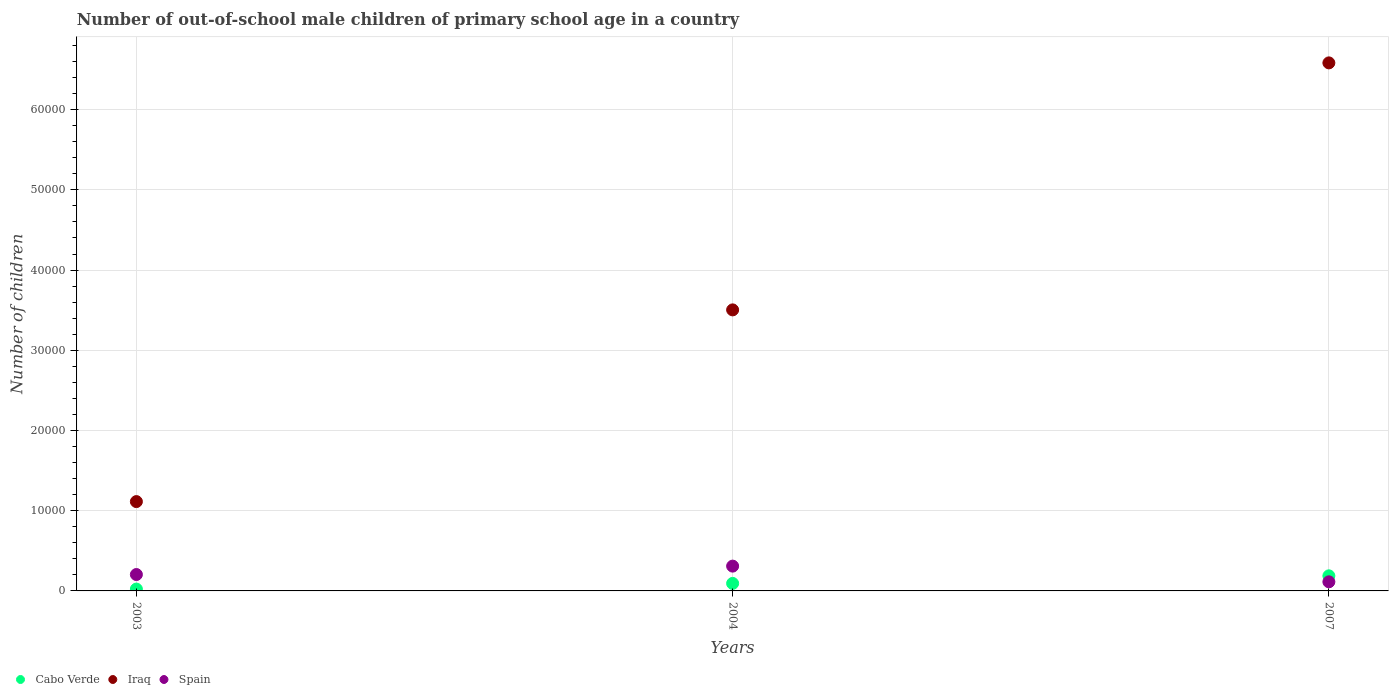What is the number of out-of-school male children in Spain in 2007?
Your answer should be compact. 1134. Across all years, what is the maximum number of out-of-school male children in Iraq?
Your answer should be compact. 6.58e+04. Across all years, what is the minimum number of out-of-school male children in Spain?
Ensure brevity in your answer.  1134. In which year was the number of out-of-school male children in Spain maximum?
Your answer should be compact. 2004. In which year was the number of out-of-school male children in Spain minimum?
Give a very brief answer. 2007. What is the total number of out-of-school male children in Spain in the graph?
Provide a short and direct response. 6270. What is the difference between the number of out-of-school male children in Iraq in 2004 and that in 2007?
Offer a very short reply. -3.08e+04. What is the difference between the number of out-of-school male children in Cabo Verde in 2003 and the number of out-of-school male children in Iraq in 2007?
Make the answer very short. -6.56e+04. What is the average number of out-of-school male children in Cabo Verde per year?
Give a very brief answer. 1016. In the year 2007, what is the difference between the number of out-of-school male children in Spain and number of out-of-school male children in Iraq?
Offer a very short reply. -6.47e+04. In how many years, is the number of out-of-school male children in Iraq greater than 30000?
Offer a very short reply. 2. What is the ratio of the number of out-of-school male children in Iraq in 2004 to that in 2007?
Your answer should be compact. 0.53. Is the number of out-of-school male children in Spain in 2003 less than that in 2004?
Provide a short and direct response. Yes. Is the difference between the number of out-of-school male children in Spain in 2003 and 2007 greater than the difference between the number of out-of-school male children in Iraq in 2003 and 2007?
Make the answer very short. Yes. What is the difference between the highest and the second highest number of out-of-school male children in Iraq?
Offer a terse response. 3.08e+04. What is the difference between the highest and the lowest number of out-of-school male children in Iraq?
Ensure brevity in your answer.  5.47e+04. In how many years, is the number of out-of-school male children in Iraq greater than the average number of out-of-school male children in Iraq taken over all years?
Ensure brevity in your answer.  1. Is it the case that in every year, the sum of the number of out-of-school male children in Iraq and number of out-of-school male children in Spain  is greater than the number of out-of-school male children in Cabo Verde?
Your response must be concise. Yes. Is the number of out-of-school male children in Cabo Verde strictly greater than the number of out-of-school male children in Spain over the years?
Keep it short and to the point. No. How many dotlines are there?
Provide a succinct answer. 3. What is the difference between two consecutive major ticks on the Y-axis?
Your response must be concise. 10000. Are the values on the major ticks of Y-axis written in scientific E-notation?
Offer a terse response. No. Does the graph contain any zero values?
Your answer should be very brief. No. Does the graph contain grids?
Make the answer very short. Yes. What is the title of the graph?
Ensure brevity in your answer.  Number of out-of-school male children of primary school age in a country. Does "Niger" appear as one of the legend labels in the graph?
Your response must be concise. No. What is the label or title of the X-axis?
Offer a terse response. Years. What is the label or title of the Y-axis?
Keep it short and to the point. Number of children. What is the Number of children in Cabo Verde in 2003?
Your answer should be compact. 230. What is the Number of children in Iraq in 2003?
Offer a terse response. 1.11e+04. What is the Number of children in Spain in 2003?
Offer a terse response. 2044. What is the Number of children in Cabo Verde in 2004?
Your answer should be very brief. 937. What is the Number of children in Iraq in 2004?
Offer a terse response. 3.50e+04. What is the Number of children in Spain in 2004?
Your response must be concise. 3092. What is the Number of children in Cabo Verde in 2007?
Offer a terse response. 1881. What is the Number of children in Iraq in 2007?
Make the answer very short. 6.58e+04. What is the Number of children in Spain in 2007?
Your answer should be very brief. 1134. Across all years, what is the maximum Number of children in Cabo Verde?
Your answer should be compact. 1881. Across all years, what is the maximum Number of children of Iraq?
Your answer should be compact. 6.58e+04. Across all years, what is the maximum Number of children in Spain?
Your answer should be very brief. 3092. Across all years, what is the minimum Number of children in Cabo Verde?
Provide a short and direct response. 230. Across all years, what is the minimum Number of children in Iraq?
Offer a terse response. 1.11e+04. Across all years, what is the minimum Number of children in Spain?
Provide a short and direct response. 1134. What is the total Number of children in Cabo Verde in the graph?
Keep it short and to the point. 3048. What is the total Number of children of Iraq in the graph?
Your response must be concise. 1.12e+05. What is the total Number of children of Spain in the graph?
Offer a very short reply. 6270. What is the difference between the Number of children of Cabo Verde in 2003 and that in 2004?
Keep it short and to the point. -707. What is the difference between the Number of children of Iraq in 2003 and that in 2004?
Make the answer very short. -2.39e+04. What is the difference between the Number of children in Spain in 2003 and that in 2004?
Your answer should be compact. -1048. What is the difference between the Number of children of Cabo Verde in 2003 and that in 2007?
Ensure brevity in your answer.  -1651. What is the difference between the Number of children in Iraq in 2003 and that in 2007?
Offer a very short reply. -5.47e+04. What is the difference between the Number of children of Spain in 2003 and that in 2007?
Your answer should be compact. 910. What is the difference between the Number of children in Cabo Verde in 2004 and that in 2007?
Offer a terse response. -944. What is the difference between the Number of children of Iraq in 2004 and that in 2007?
Provide a short and direct response. -3.08e+04. What is the difference between the Number of children in Spain in 2004 and that in 2007?
Your answer should be very brief. 1958. What is the difference between the Number of children in Cabo Verde in 2003 and the Number of children in Iraq in 2004?
Provide a short and direct response. -3.48e+04. What is the difference between the Number of children in Cabo Verde in 2003 and the Number of children in Spain in 2004?
Your answer should be very brief. -2862. What is the difference between the Number of children in Iraq in 2003 and the Number of children in Spain in 2004?
Keep it short and to the point. 8045. What is the difference between the Number of children of Cabo Verde in 2003 and the Number of children of Iraq in 2007?
Your response must be concise. -6.56e+04. What is the difference between the Number of children of Cabo Verde in 2003 and the Number of children of Spain in 2007?
Your answer should be compact. -904. What is the difference between the Number of children of Iraq in 2003 and the Number of children of Spain in 2007?
Your answer should be compact. 1.00e+04. What is the difference between the Number of children in Cabo Verde in 2004 and the Number of children in Iraq in 2007?
Keep it short and to the point. -6.49e+04. What is the difference between the Number of children of Cabo Verde in 2004 and the Number of children of Spain in 2007?
Your answer should be compact. -197. What is the difference between the Number of children of Iraq in 2004 and the Number of children of Spain in 2007?
Your answer should be very brief. 3.39e+04. What is the average Number of children of Cabo Verde per year?
Your response must be concise. 1016. What is the average Number of children in Iraq per year?
Ensure brevity in your answer.  3.73e+04. What is the average Number of children in Spain per year?
Offer a terse response. 2090. In the year 2003, what is the difference between the Number of children in Cabo Verde and Number of children in Iraq?
Ensure brevity in your answer.  -1.09e+04. In the year 2003, what is the difference between the Number of children in Cabo Verde and Number of children in Spain?
Make the answer very short. -1814. In the year 2003, what is the difference between the Number of children of Iraq and Number of children of Spain?
Keep it short and to the point. 9093. In the year 2004, what is the difference between the Number of children of Cabo Verde and Number of children of Iraq?
Keep it short and to the point. -3.41e+04. In the year 2004, what is the difference between the Number of children in Cabo Verde and Number of children in Spain?
Offer a terse response. -2155. In the year 2004, what is the difference between the Number of children in Iraq and Number of children in Spain?
Keep it short and to the point. 3.19e+04. In the year 2007, what is the difference between the Number of children in Cabo Verde and Number of children in Iraq?
Your response must be concise. -6.40e+04. In the year 2007, what is the difference between the Number of children in Cabo Verde and Number of children in Spain?
Ensure brevity in your answer.  747. In the year 2007, what is the difference between the Number of children of Iraq and Number of children of Spain?
Provide a short and direct response. 6.47e+04. What is the ratio of the Number of children in Cabo Verde in 2003 to that in 2004?
Provide a short and direct response. 0.25. What is the ratio of the Number of children of Iraq in 2003 to that in 2004?
Provide a succinct answer. 0.32. What is the ratio of the Number of children of Spain in 2003 to that in 2004?
Provide a succinct answer. 0.66. What is the ratio of the Number of children of Cabo Verde in 2003 to that in 2007?
Offer a very short reply. 0.12. What is the ratio of the Number of children in Iraq in 2003 to that in 2007?
Provide a short and direct response. 0.17. What is the ratio of the Number of children in Spain in 2003 to that in 2007?
Make the answer very short. 1.8. What is the ratio of the Number of children of Cabo Verde in 2004 to that in 2007?
Give a very brief answer. 0.5. What is the ratio of the Number of children in Iraq in 2004 to that in 2007?
Provide a short and direct response. 0.53. What is the ratio of the Number of children in Spain in 2004 to that in 2007?
Provide a succinct answer. 2.73. What is the difference between the highest and the second highest Number of children in Cabo Verde?
Make the answer very short. 944. What is the difference between the highest and the second highest Number of children in Iraq?
Ensure brevity in your answer.  3.08e+04. What is the difference between the highest and the second highest Number of children in Spain?
Provide a succinct answer. 1048. What is the difference between the highest and the lowest Number of children of Cabo Verde?
Your answer should be very brief. 1651. What is the difference between the highest and the lowest Number of children of Iraq?
Your response must be concise. 5.47e+04. What is the difference between the highest and the lowest Number of children in Spain?
Your answer should be compact. 1958. 